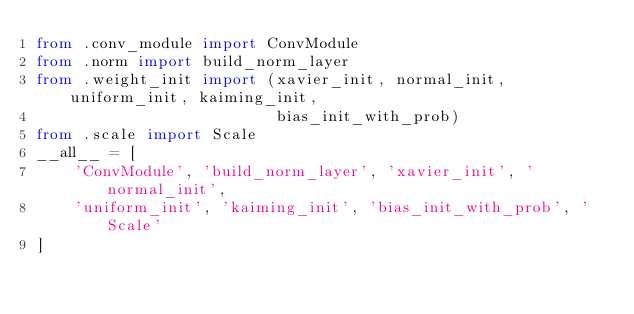<code> <loc_0><loc_0><loc_500><loc_500><_Python_>from .conv_module import ConvModule
from .norm import build_norm_layer
from .weight_init import (xavier_init, normal_init, uniform_init, kaiming_init,
                          bias_init_with_prob)
from .scale import Scale
__all__ = [
    'ConvModule', 'build_norm_layer', 'xavier_init', 'normal_init',
    'uniform_init', 'kaiming_init', 'bias_init_with_prob', 'Scale'
]
</code> 